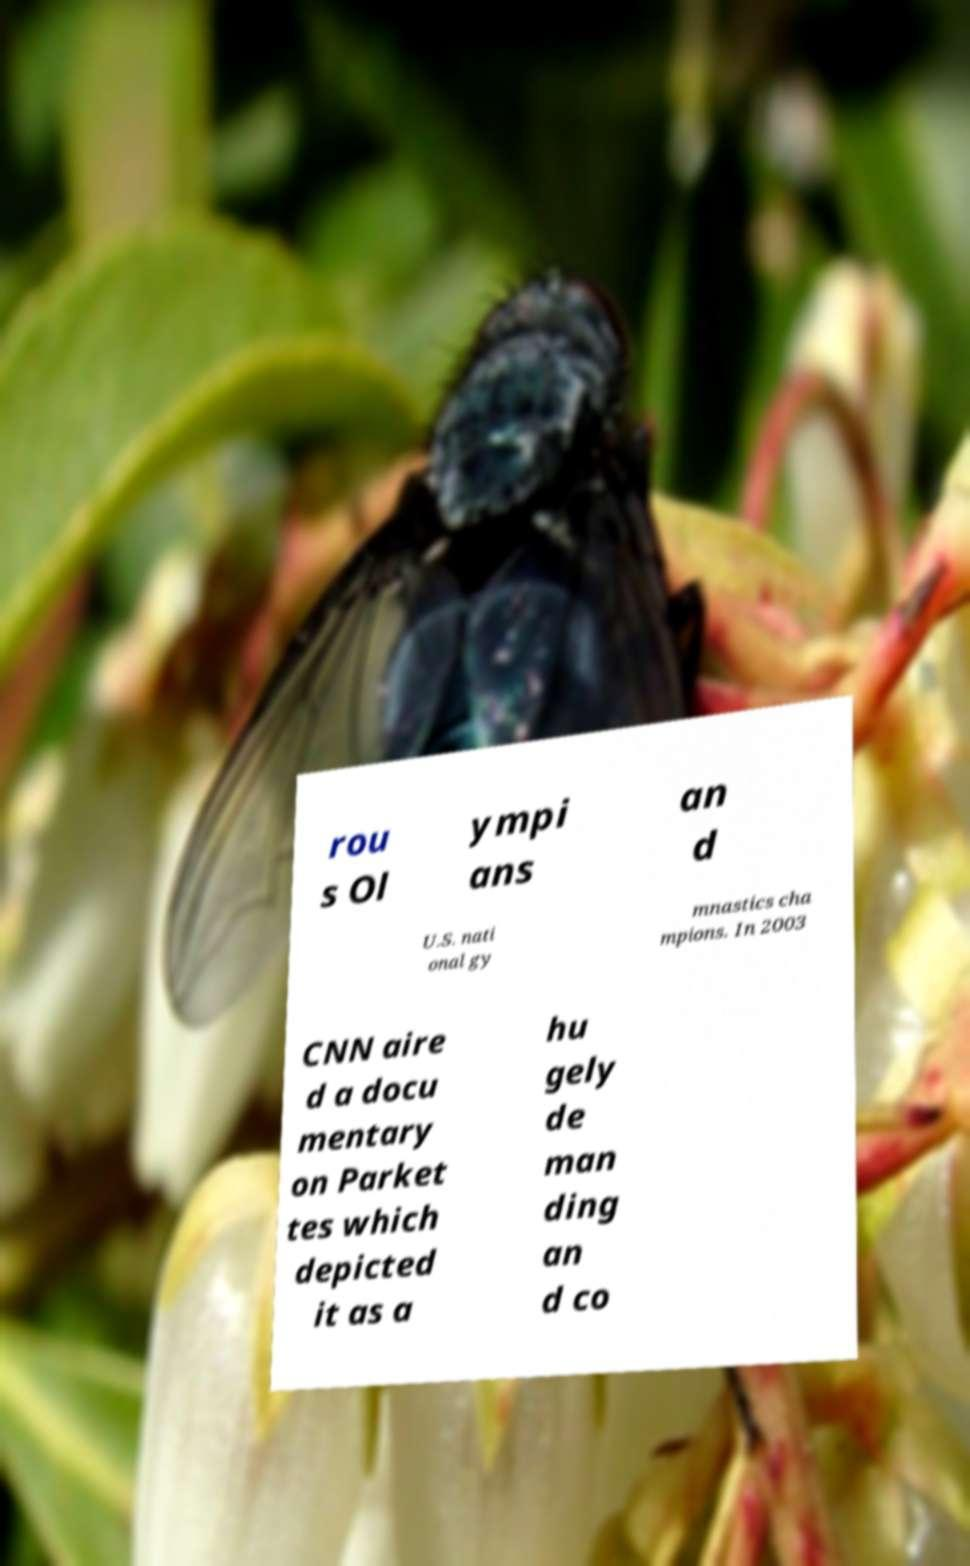What messages or text are displayed in this image? I need them in a readable, typed format. rou s Ol ympi ans an d U.S. nati onal gy mnastics cha mpions. In 2003 CNN aire d a docu mentary on Parket tes which depicted it as a hu gely de man ding an d co 